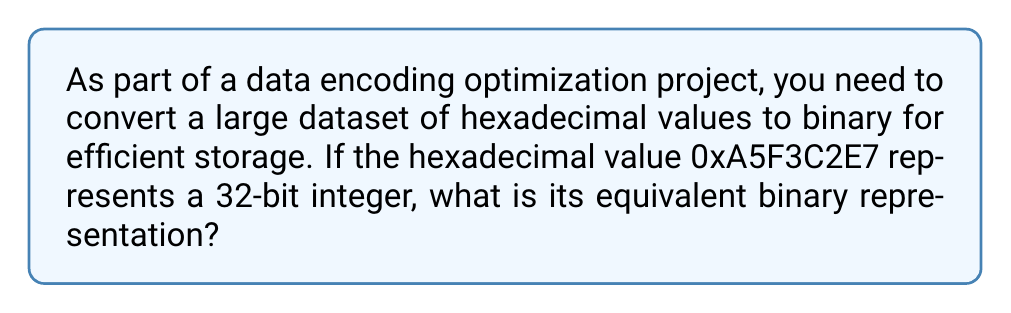What is the answer to this math problem? To convert a hexadecimal number to binary, we can follow these steps:

1. First, let's recall that each hexadecimal digit represents 4 binary digits (bits).

2. We can create a conversion table for hexadecimal to binary:

   0 = 0000   4 = 0100   8 = 1000   C = 1100
   1 = 0001   5 = 0101   9 = 1001   D = 1101
   2 = 0010   6 = 0110   A = 1010   E = 1110
   3 = 0011   7 = 0111   B = 1011   F = 1111

3. Now, let's convert each hexadecimal digit to its 4-bit binary equivalent:

   A = 1010
   5 = 0101
   F = 1111
   3 = 0011
   C = 1100
   2 = 0010
   E = 1110
   7 = 0111

4. Finally, we concatenate these binary values in the same order as the original hexadecimal number:

   $$\text{0xA5F3C2E7} = 1010 0101 1111 0011 1100 0010 1110 0111$$

This gives us the 32-bit binary representation of the original hexadecimal number.
Answer: 10100101111100111100001011100111 